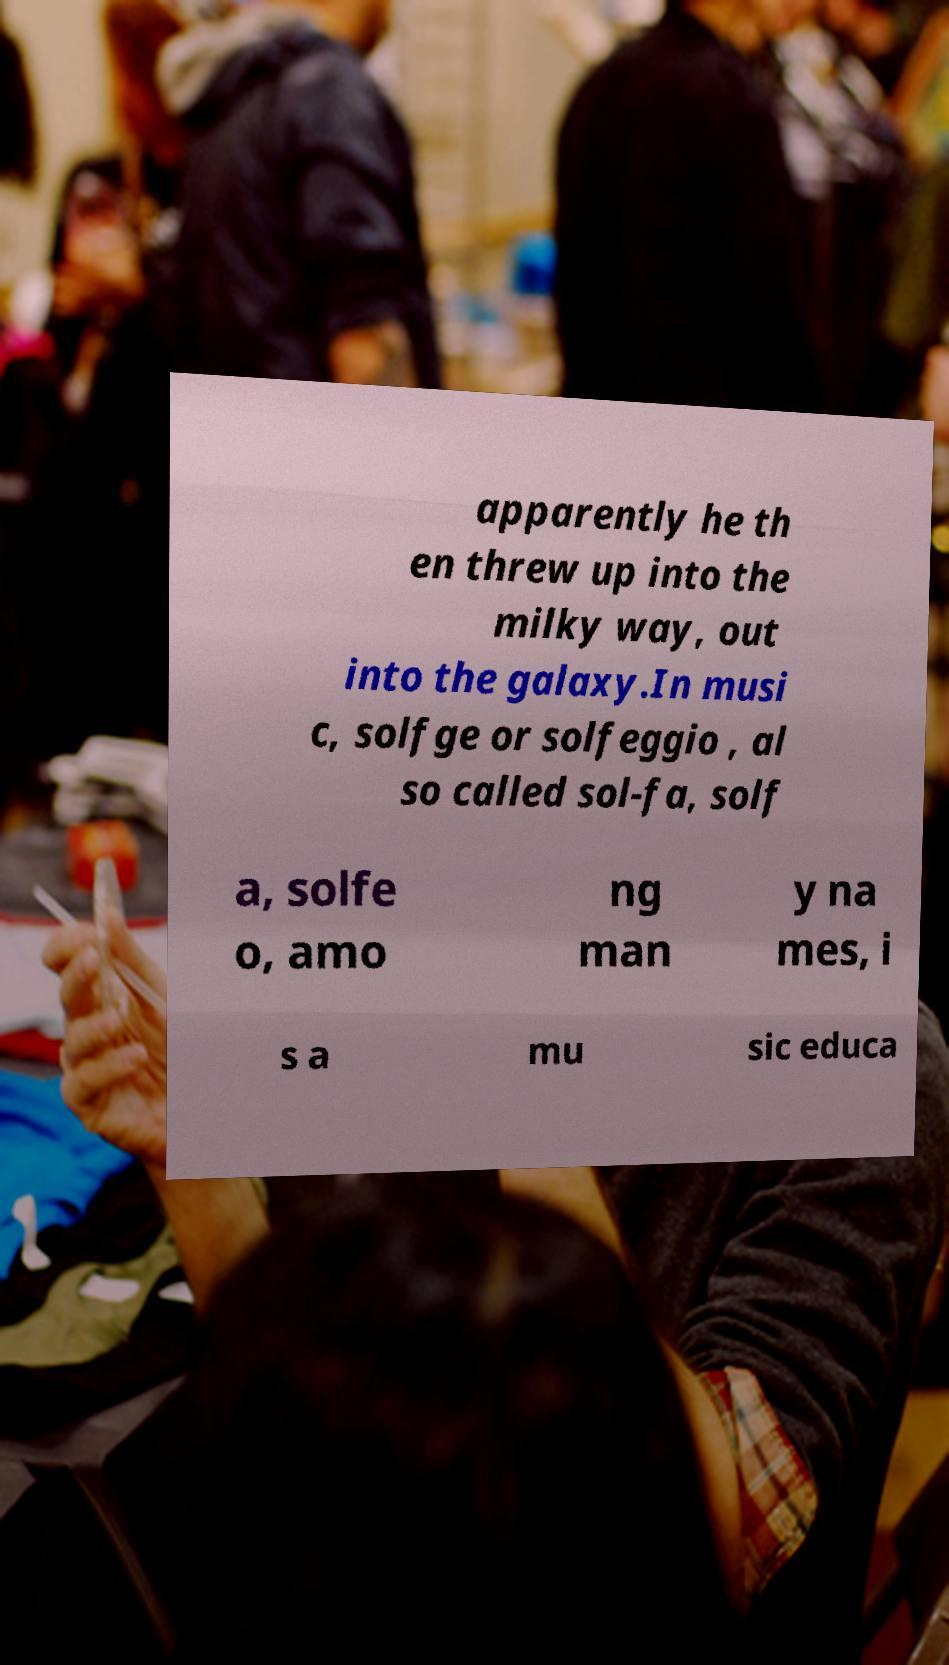Please identify and transcribe the text found in this image. apparently he th en threw up into the milky way, out into the galaxy.In musi c, solfge or solfeggio , al so called sol-fa, solf a, solfe o, amo ng man y na mes, i s a mu sic educa 